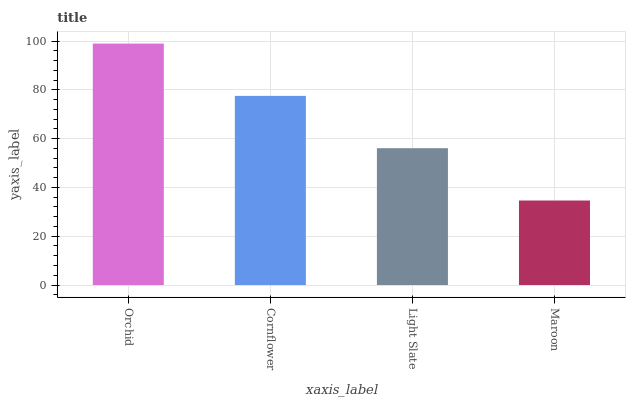Is Cornflower the minimum?
Answer yes or no. No. Is Cornflower the maximum?
Answer yes or no. No. Is Orchid greater than Cornflower?
Answer yes or no. Yes. Is Cornflower less than Orchid?
Answer yes or no. Yes. Is Cornflower greater than Orchid?
Answer yes or no. No. Is Orchid less than Cornflower?
Answer yes or no. No. Is Cornflower the high median?
Answer yes or no. Yes. Is Light Slate the low median?
Answer yes or no. Yes. Is Maroon the high median?
Answer yes or no. No. Is Cornflower the low median?
Answer yes or no. No. 